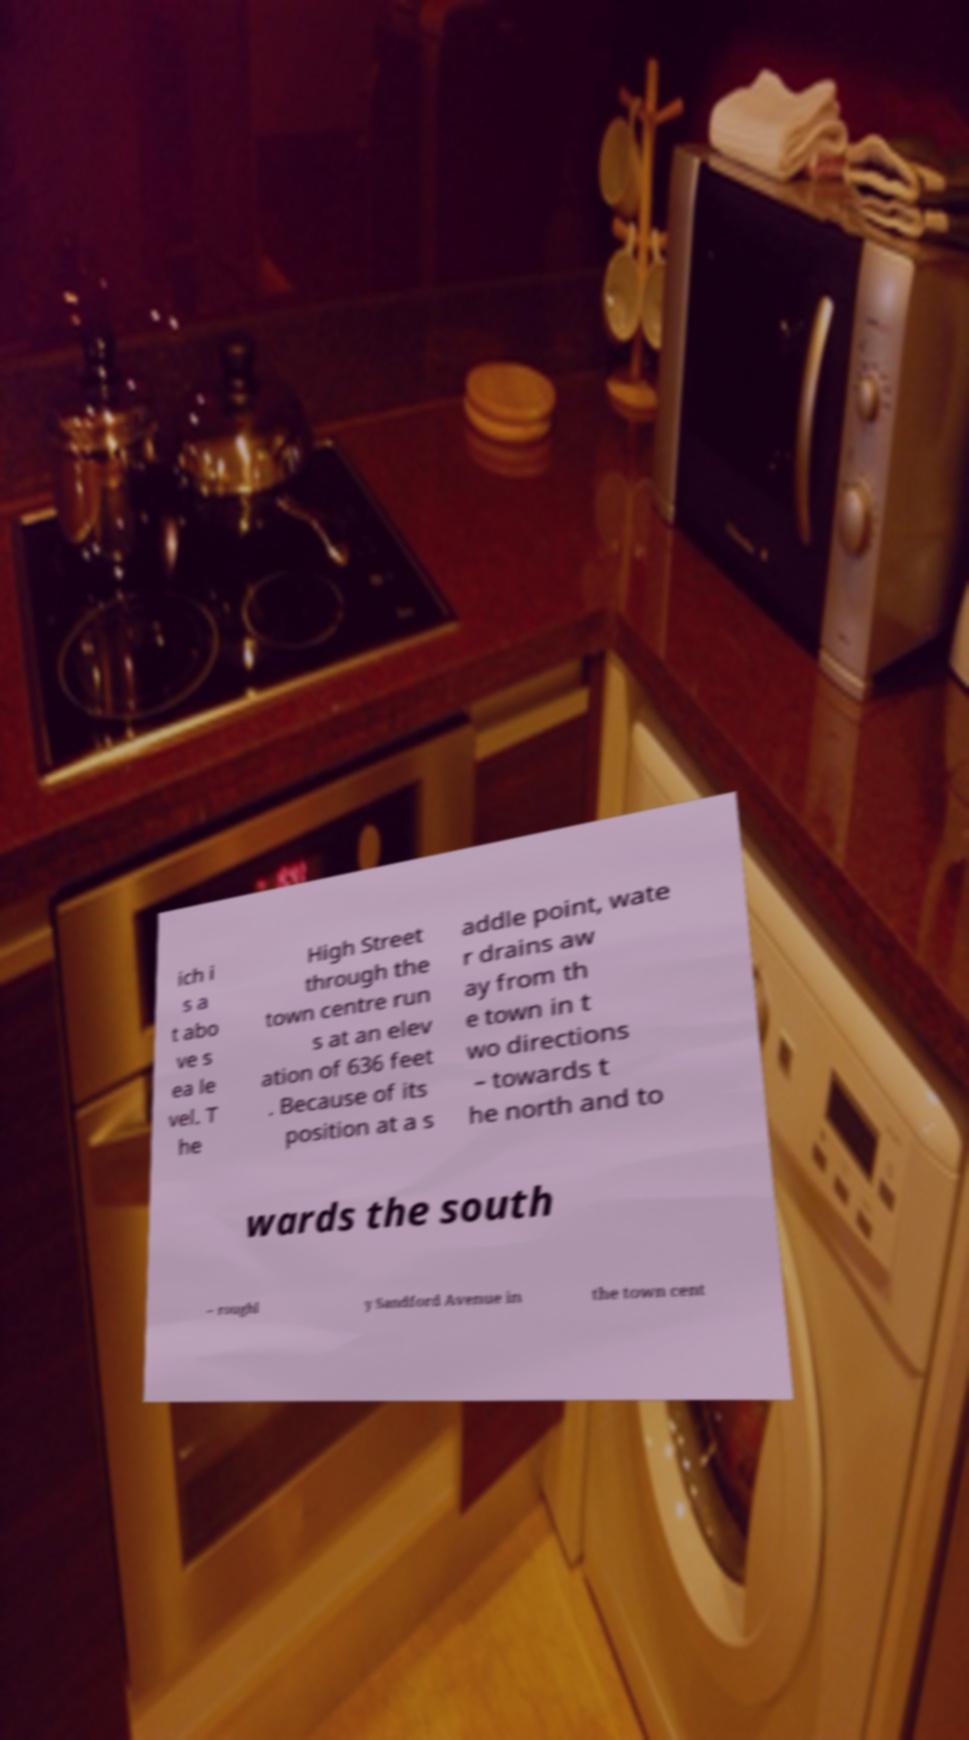There's text embedded in this image that I need extracted. Can you transcribe it verbatim? ich i s a t abo ve s ea le vel. T he High Street through the town centre run s at an elev ation of 636 feet . Because of its position at a s addle point, wate r drains aw ay from th e town in t wo directions – towards t he north and to wards the south – roughl y Sandford Avenue in the town cent 